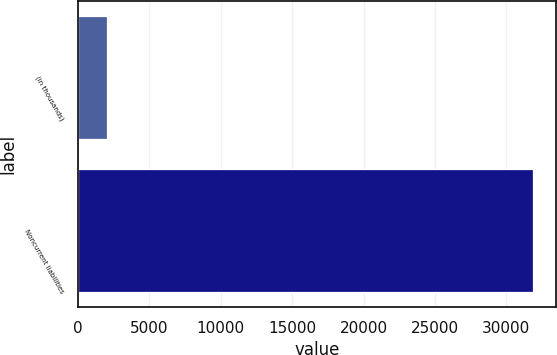Convert chart to OTSL. <chart><loc_0><loc_0><loc_500><loc_500><bar_chart><fcel>(in thousands)<fcel>Noncurrent liabilities<nl><fcel>2011<fcel>31867<nl></chart> 